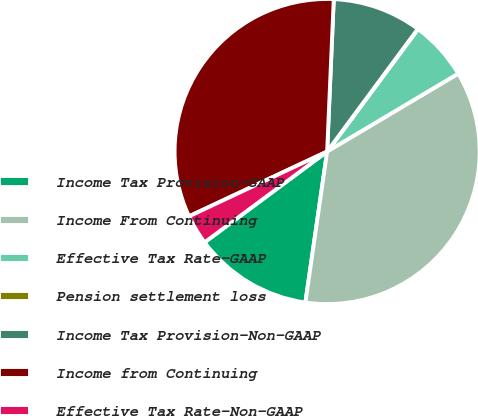Convert chart to OTSL. <chart><loc_0><loc_0><loc_500><loc_500><pie_chart><fcel>Income Tax Provision-GAAP<fcel>Income From Continuing<fcel>Effective Tax Rate-GAAP<fcel>Pension settlement loss<fcel>Income Tax Provision-Non-GAAP<fcel>Income from Continuing<fcel>Effective Tax Rate-Non-GAAP<nl><fcel>12.57%<fcel>35.81%<fcel>6.3%<fcel>0.03%<fcel>9.44%<fcel>32.67%<fcel>3.17%<nl></chart> 